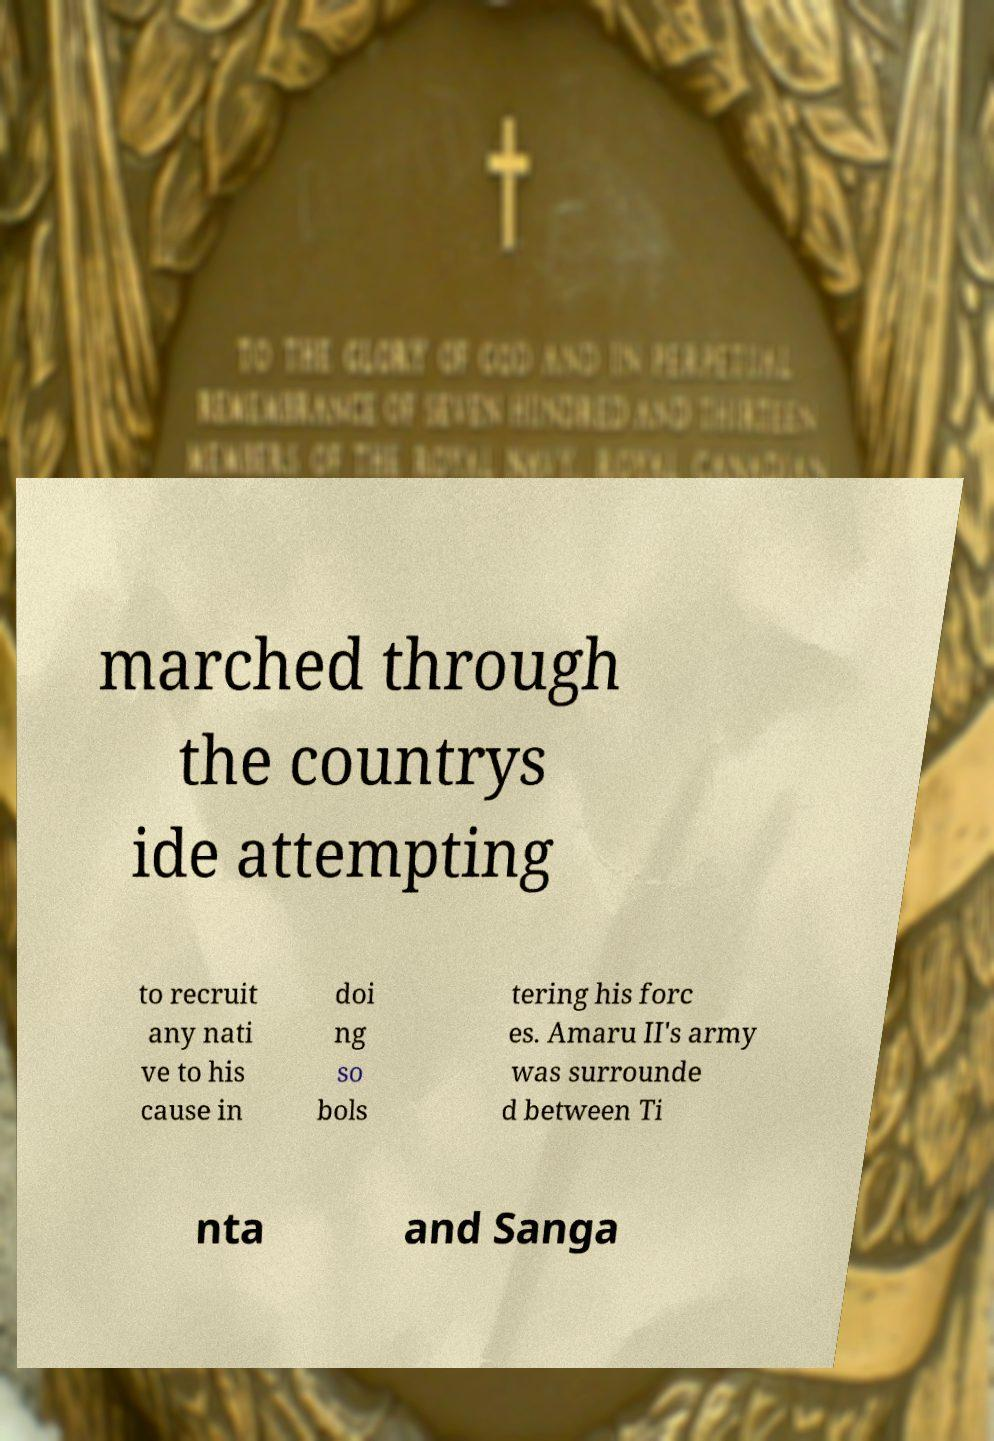For documentation purposes, I need the text within this image transcribed. Could you provide that? marched through the countrys ide attempting to recruit any nati ve to his cause in doi ng so bols tering his forc es. Amaru II's army was surrounde d between Ti nta and Sanga 